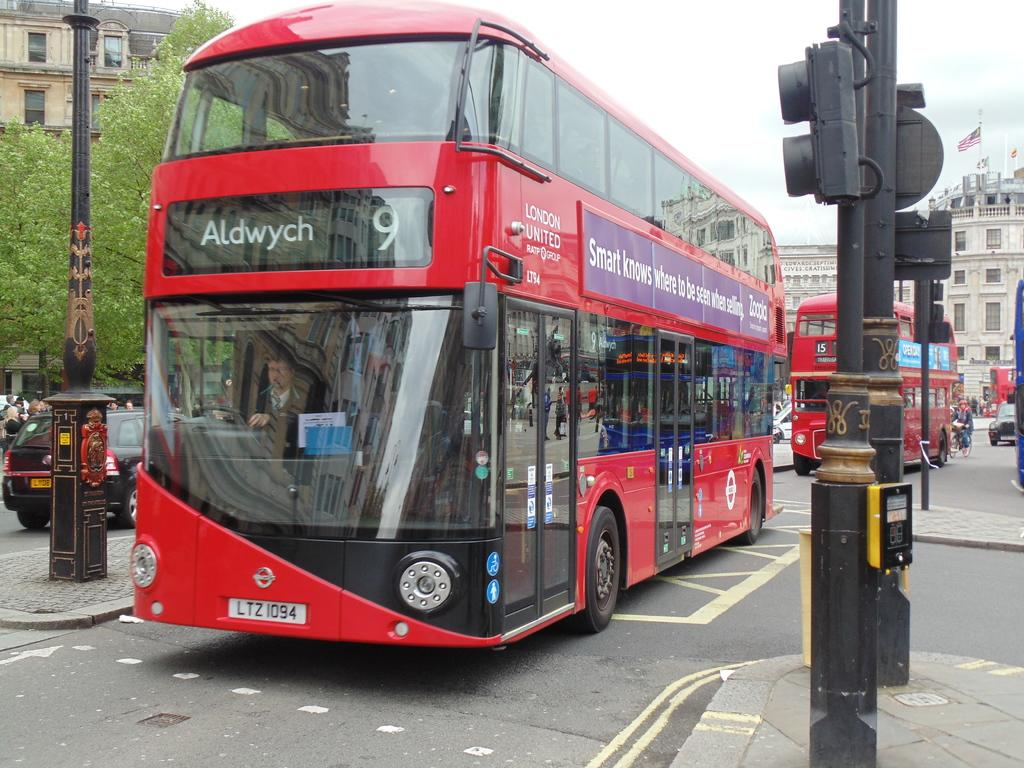How many double-decker buses can be seen on the road in the image? There are two double-decker buses on the road in the image. What else can be seen in the background of the image? Buildings and trees are visible in the image. What type of vehicles are present in the image besides the buses? Cars are visible in the image. Are there any people in the image? Yes, people are present in the image. What else can be seen on the road or sidewalk in the image? There are poles with lights in the image. Are there any cobwebs visible on the double-decker buses in the image? There is no mention of cobwebs in the image, so it cannot be determined if any are present. 